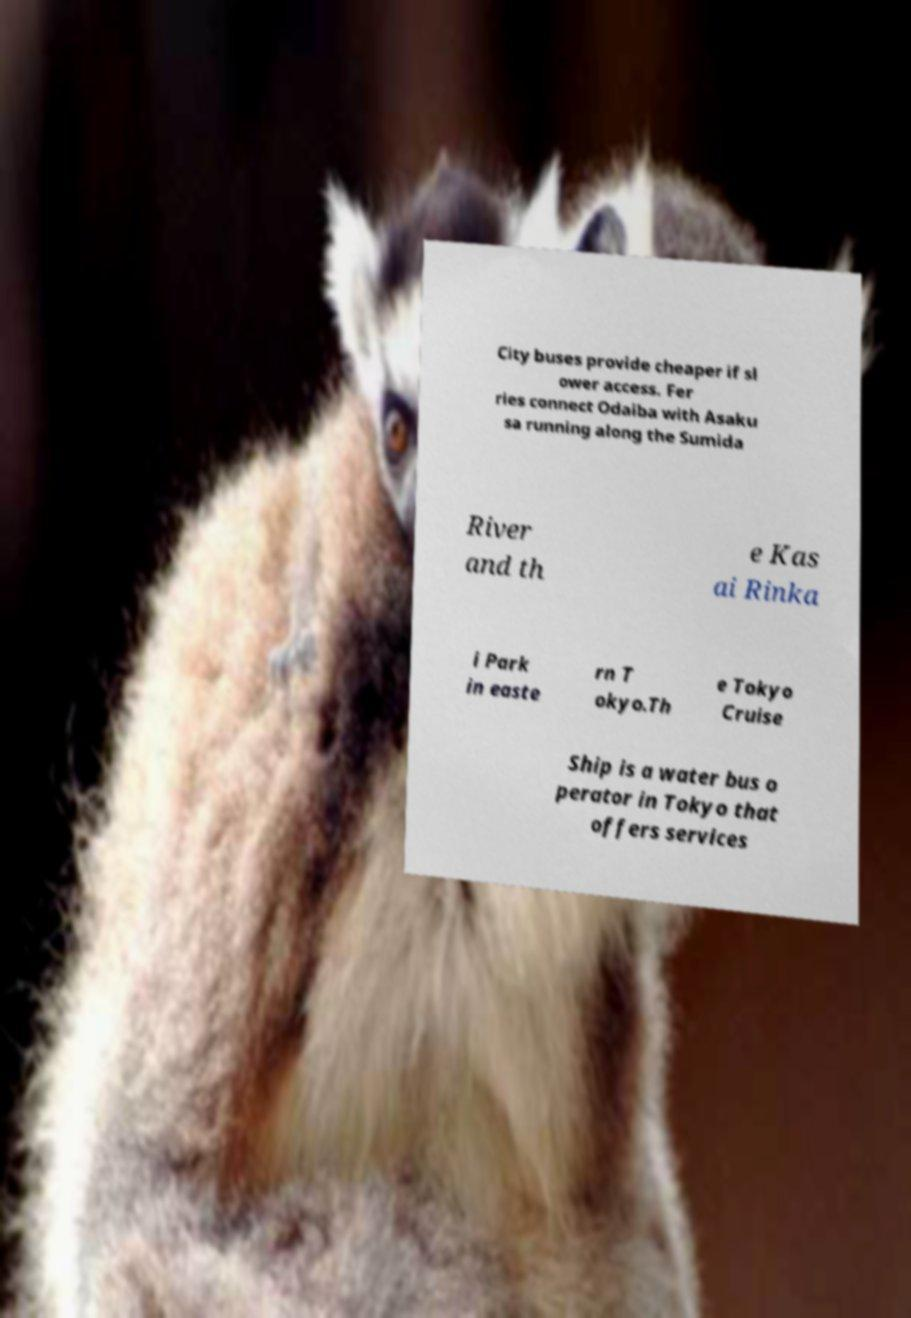Please identify and transcribe the text found in this image. City buses provide cheaper if sl ower access. Fer ries connect Odaiba with Asaku sa running along the Sumida River and th e Kas ai Rinka i Park in easte rn T okyo.Th e Tokyo Cruise Ship is a water bus o perator in Tokyo that offers services 